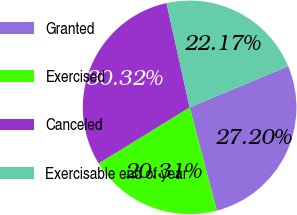Convert chart to OTSL. <chart><loc_0><loc_0><loc_500><loc_500><pie_chart><fcel>Granted<fcel>Exercised<fcel>Canceled<fcel>Exercisable end of year<nl><fcel>27.2%<fcel>20.31%<fcel>30.32%<fcel>22.17%<nl></chart> 